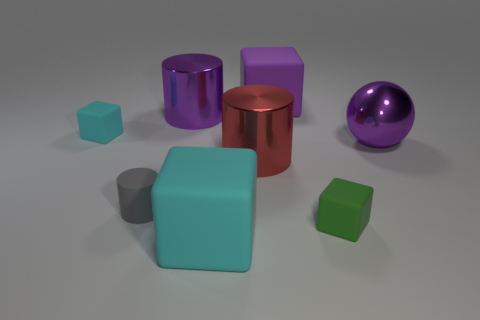There is a metallic cylinder that is the same color as the sphere; what is its size?
Offer a very short reply. Large. How many big objects are behind the tiny cyan rubber block and in front of the small cyan block?
Provide a succinct answer. 0. The other tiny thing that is the same shape as the small cyan thing is what color?
Offer a very short reply. Green. Is the number of purple metallic cylinders less than the number of large brown cylinders?
Offer a very short reply. No. There is a red cylinder; is it the same size as the cyan matte thing behind the large red metallic object?
Give a very brief answer. No. There is a tiny block that is behind the big metallic ball in front of the large purple cylinder; what color is it?
Your response must be concise. Cyan. What number of things are large rubber objects behind the big red cylinder or small objects that are behind the small matte cylinder?
Provide a succinct answer. 2. Do the gray object and the green object have the same size?
Keep it short and to the point. Yes. Is the shape of the purple shiny thing on the left side of the green thing the same as the tiny gray object that is to the left of the big cyan cube?
Make the answer very short. Yes. How big is the purple cylinder?
Give a very brief answer. Large. 